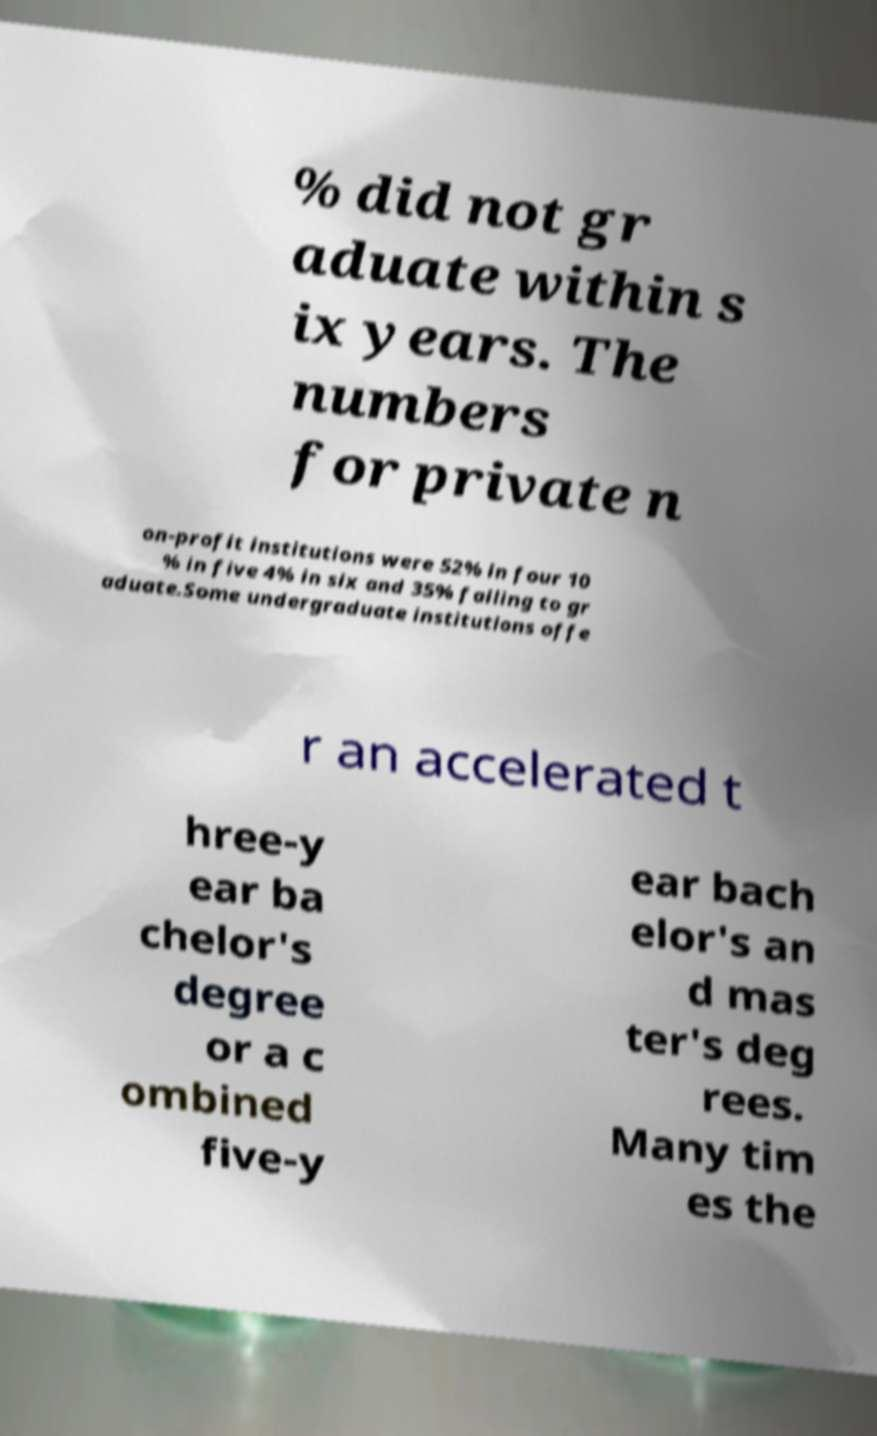Can you accurately transcribe the text from the provided image for me? % did not gr aduate within s ix years. The numbers for private n on-profit institutions were 52% in four 10 % in five 4% in six and 35% failing to gr aduate.Some undergraduate institutions offe r an accelerated t hree-y ear ba chelor's degree or a c ombined five-y ear bach elor's an d mas ter's deg rees. Many tim es the 